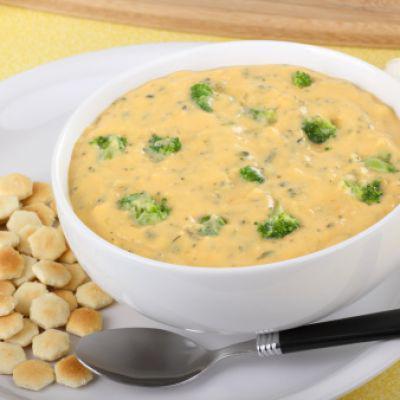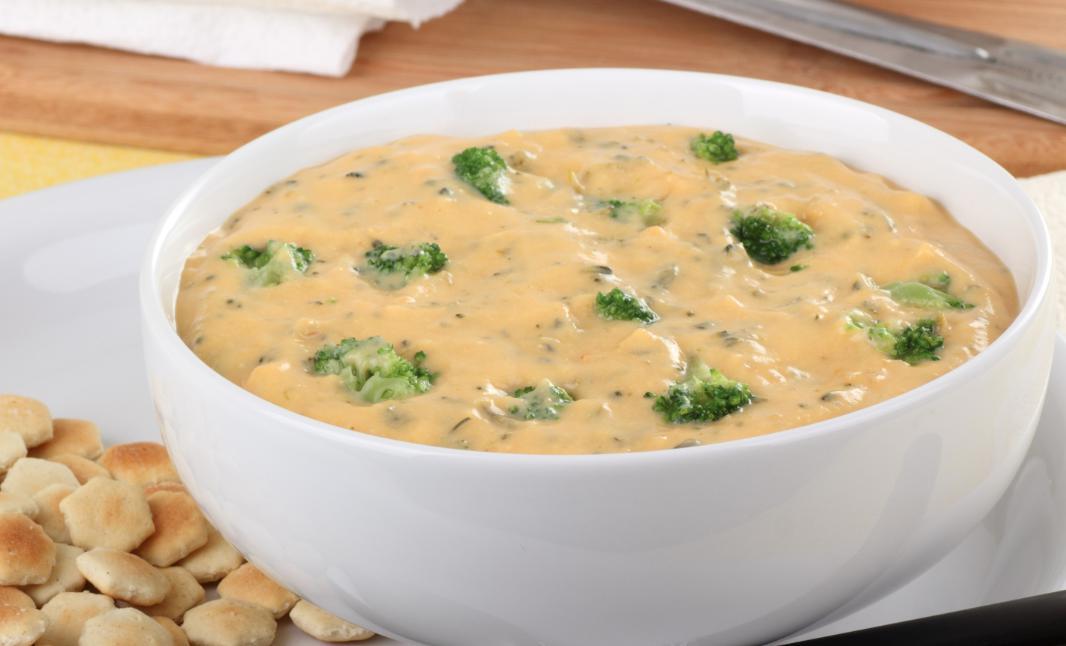The first image is the image on the left, the second image is the image on the right. Considering the images on both sides, is "At least one bowl of soup is garnished with cheese." valid? Answer yes or no. No. 